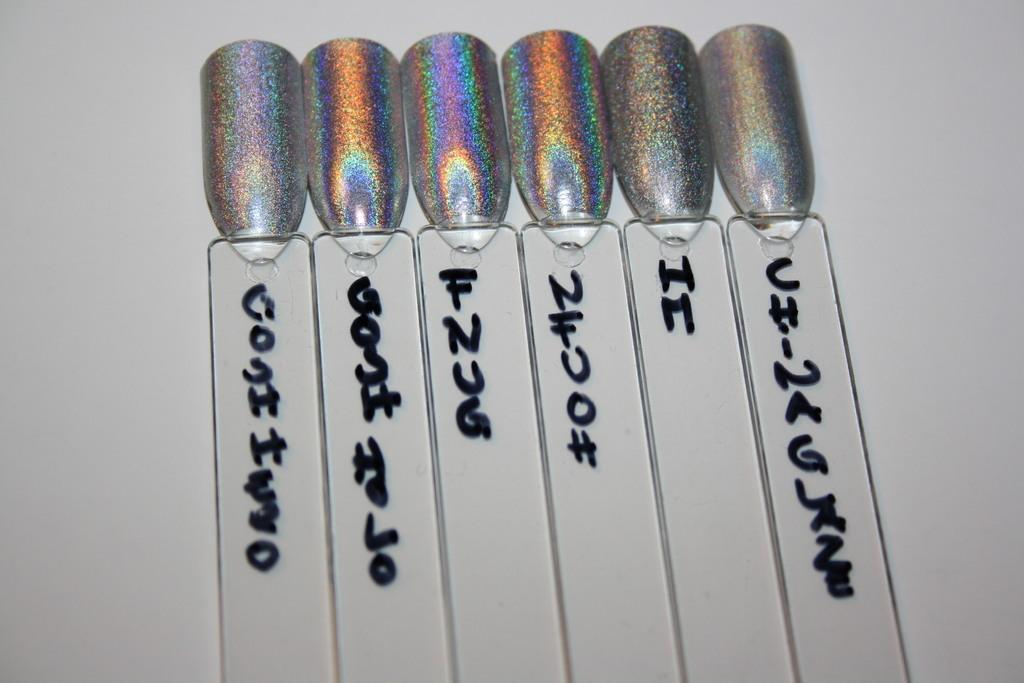What can be observed on some objects in the image? There is text written on some objects in the image. What is the name of the daughter mentioned in the image? There is no mention of a daughter or any personal names in the image. 